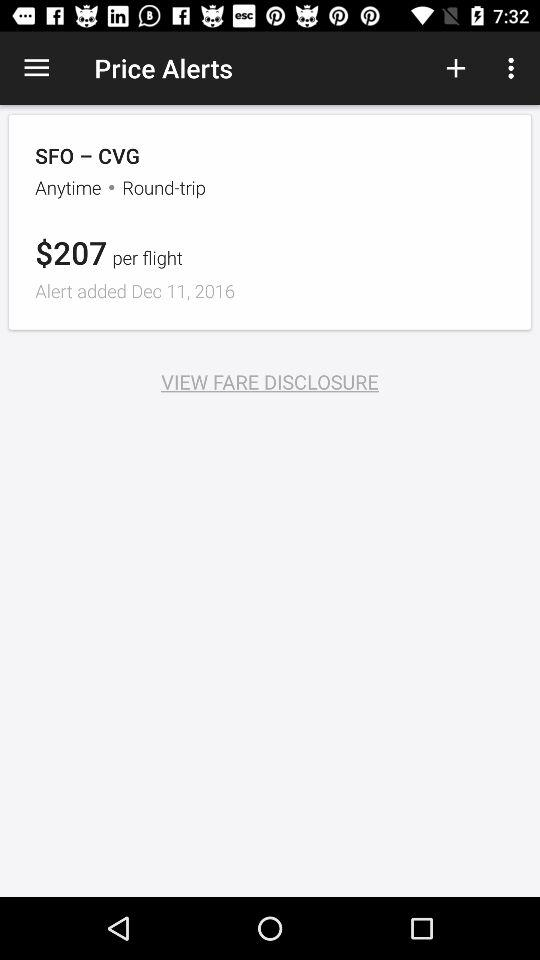When was the alert added? The alert was added on December 11, 2016. 